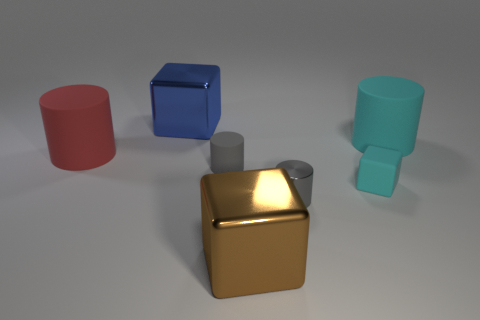What number of things are cyan cubes or large things left of the large cyan object?
Provide a succinct answer. 4. There is a brown cube that is the same size as the red object; what is its material?
Give a very brief answer. Metal. Are the big red cylinder and the cyan block made of the same material?
Ensure brevity in your answer.  Yes. What is the color of the rubber thing that is to the right of the small metal cylinder and in front of the big cyan cylinder?
Provide a short and direct response. Cyan. There is a big cube that is in front of the large red cylinder; does it have the same color as the metallic cylinder?
Make the answer very short. No. What shape is the cyan thing that is the same size as the brown thing?
Offer a very short reply. Cylinder. How many other things are the same color as the tiny matte cylinder?
Your response must be concise. 1. What number of other objects are the same material as the red object?
Ensure brevity in your answer.  3. There is a blue thing; is its size the same as the matte cylinder on the right side of the small cyan object?
Ensure brevity in your answer.  Yes. What is the color of the metal cylinder?
Make the answer very short. Gray. 